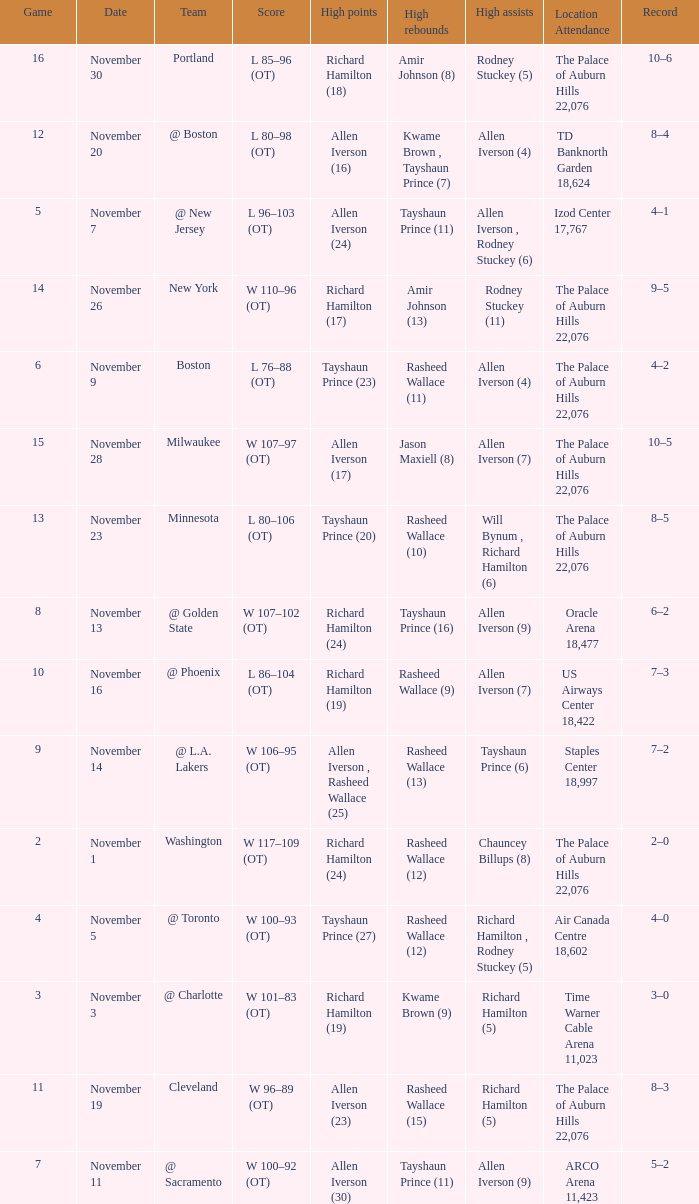What is High Points, when Game is "5"? Allen Iverson (24). 